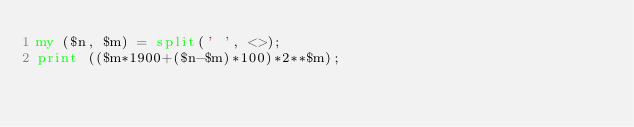Convert code to text. <code><loc_0><loc_0><loc_500><loc_500><_Perl_>my ($n, $m) = split(' ', <>);
print (($m*1900+($n-$m)*100)*2**$m);</code> 